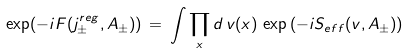<formula> <loc_0><loc_0><loc_500><loc_500>\exp ( - i F ( j _ { \pm } ^ { r e g } , A _ { \pm } ) ) \, = \, \int \prod _ { x } d \, v ( x ) \, \exp \, ( - i S _ { e f f } ( v , A _ { \pm } ) ) \,</formula> 